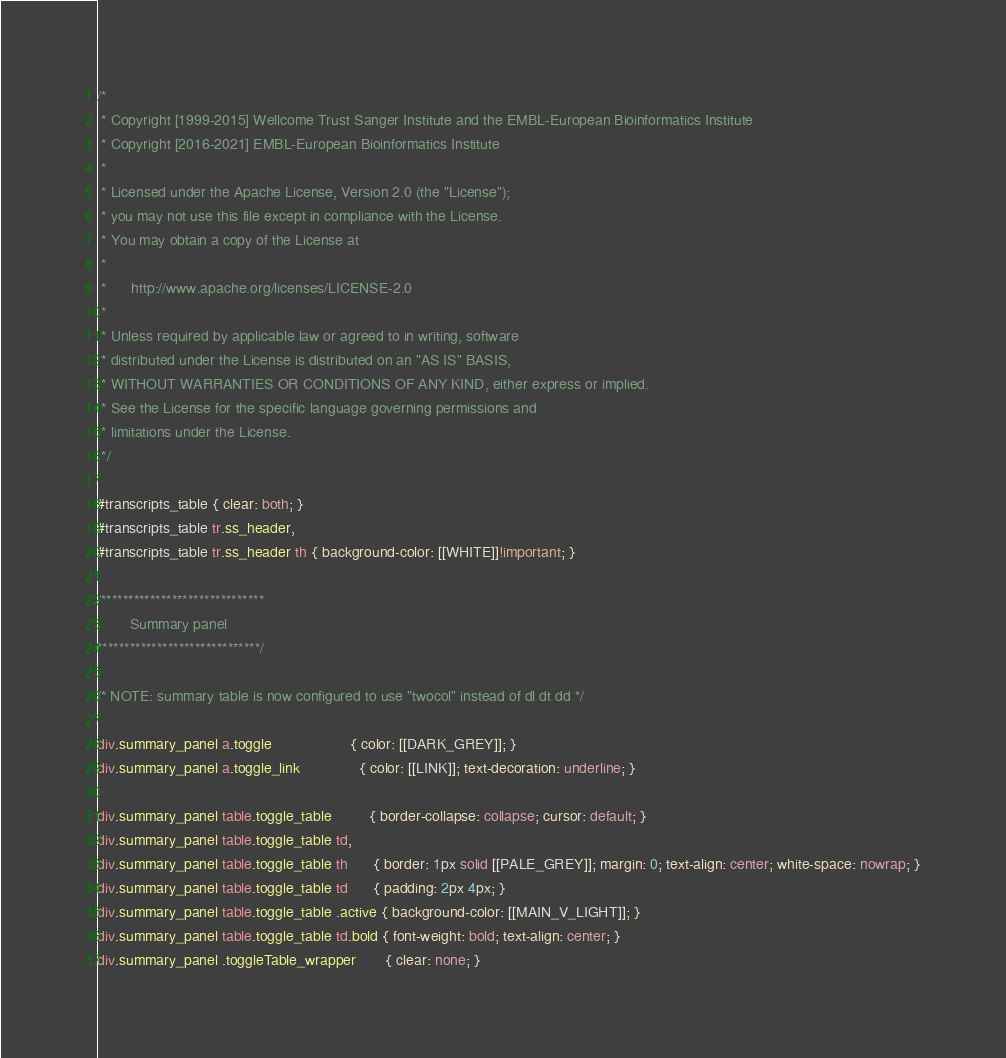<code> <loc_0><loc_0><loc_500><loc_500><_CSS_>/*
 * Copyright [1999-2015] Wellcome Trust Sanger Institute and the EMBL-European Bioinformatics Institute
 * Copyright [2016-2021] EMBL-European Bioinformatics Institute
 * 
 * Licensed under the Apache License, Version 2.0 (the "License");
 * you may not use this file except in compliance with the License.
 * You may obtain a copy of the License at
 * 
 *      http://www.apache.org/licenses/LICENSE-2.0
 * 
 * Unless required by applicable law or agreed to in writing, software
 * distributed under the License is distributed on an "AS IS" BASIS,
 * WITHOUT WARRANTIES OR CONDITIONS OF ANY KIND, either express or implied.
 * See the License for the specific language governing permissions and
 * limitations under the License.
 */

#transcripts_table { clear: both; }
#transcripts_table tr.ss_header,
#transcripts_table tr.ss_header th { background-color: [[WHITE]]!important; }

/******************************
        Summary panel
******************************/

/* NOTE: summary table is now configured to use "twocol" instead of dl dt dd */

div.summary_panel a.toggle                   { color: [[DARK_GREY]]; }
div.summary_panel a.toggle_link              { color: [[LINK]]; text-decoration: underline; }

div.summary_panel table.toggle_table         { border-collapse: collapse; cursor: default; }
div.summary_panel table.toggle_table td,
div.summary_panel table.toggle_table th      { border: 1px solid [[PALE_GREY]]; margin: 0; text-align: center; white-space: nowrap; }
div.summary_panel table.toggle_table td      { padding: 2px 4px; }
div.summary_panel table.toggle_table .active { background-color: [[MAIN_V_LIGHT]]; }
div.summary_panel table.toggle_table td.bold { font-weight: bold; text-align: center; }
div.summary_panel .toggleTable_wrapper       { clear: none; }
</code> 